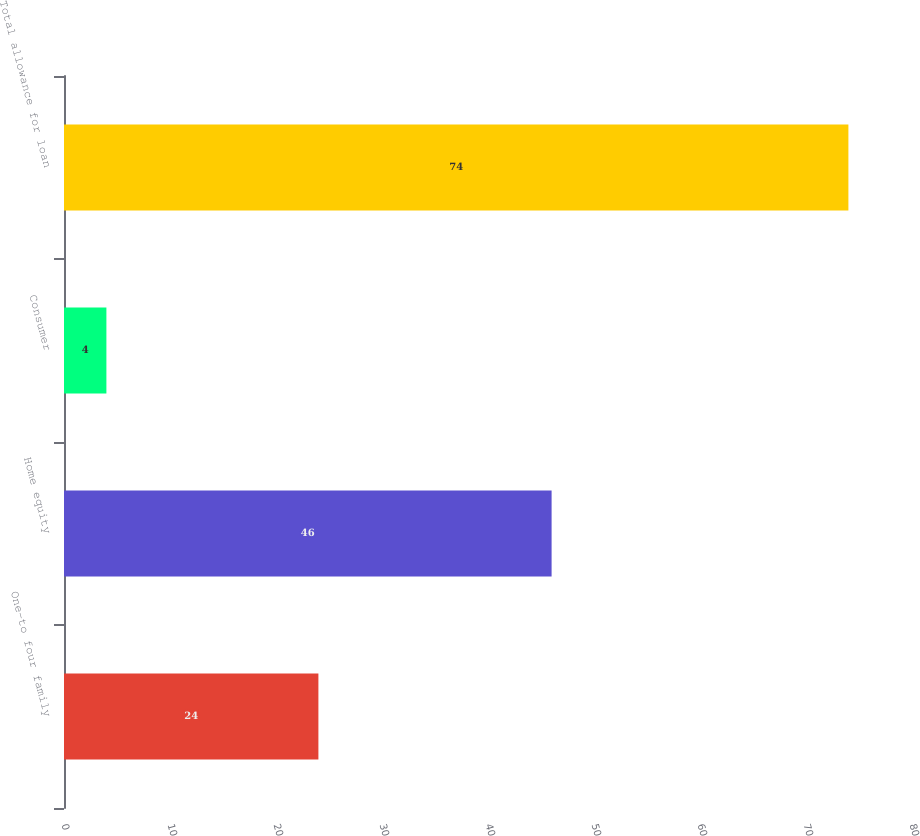Convert chart to OTSL. <chart><loc_0><loc_0><loc_500><loc_500><bar_chart><fcel>One-to four family<fcel>Home equity<fcel>Consumer<fcel>Total allowance for loan<nl><fcel>24<fcel>46<fcel>4<fcel>74<nl></chart> 